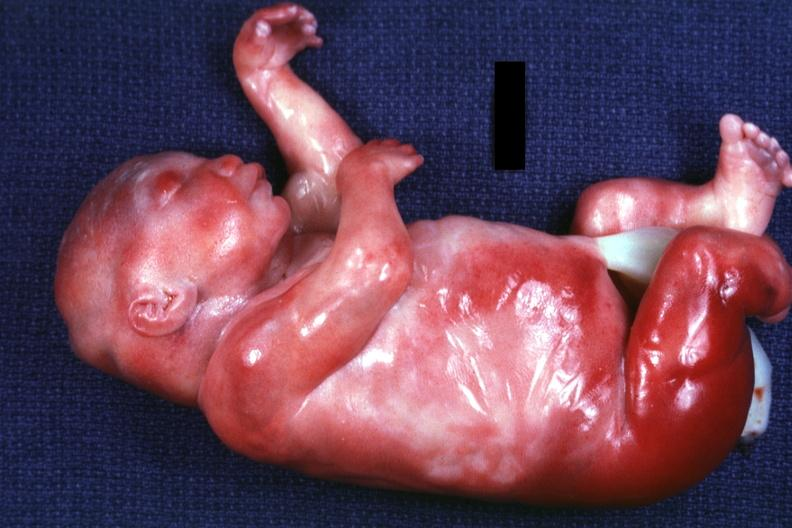what appear too short has six digits?
Answer the question using a single word or phrase. A barely seen vascular mass extruding from occipital region of skull arms and legs 